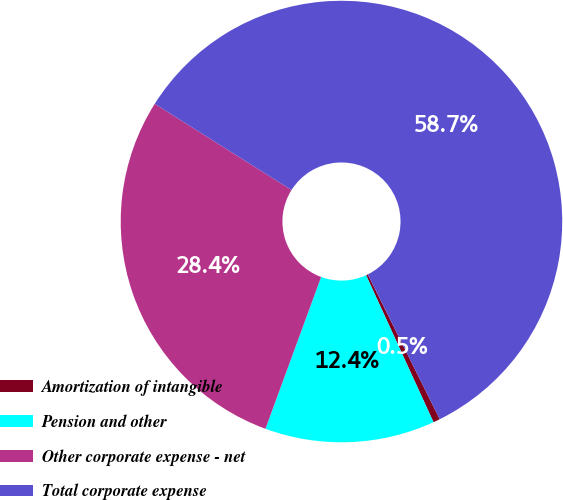Convert chart to OTSL. <chart><loc_0><loc_0><loc_500><loc_500><pie_chart><fcel>Amortization of intangible<fcel>Pension and other<fcel>Other corporate expense - net<fcel>Total corporate expense<nl><fcel>0.5%<fcel>12.44%<fcel>28.36%<fcel>58.71%<nl></chart> 